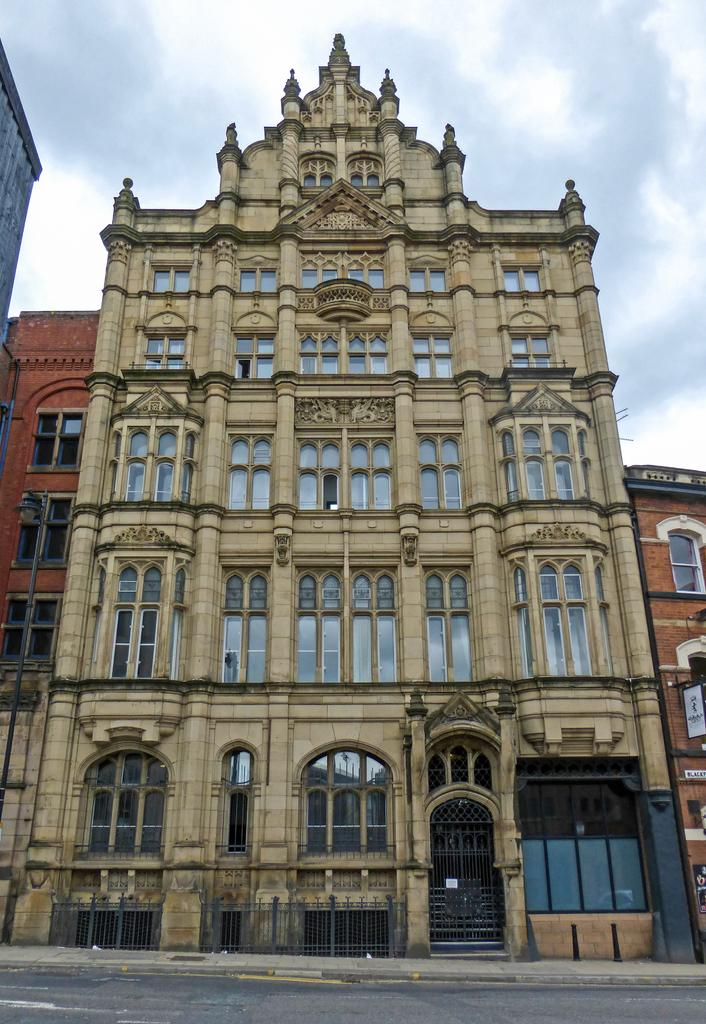What is the main subject of the image? The main subject of the image is a building. What can be seen in front of the building? There is a road in front of the building. What religion is practiced by the achiever in the image? There is no achiever or reference to religion in the image; it only shows a building and a road. 